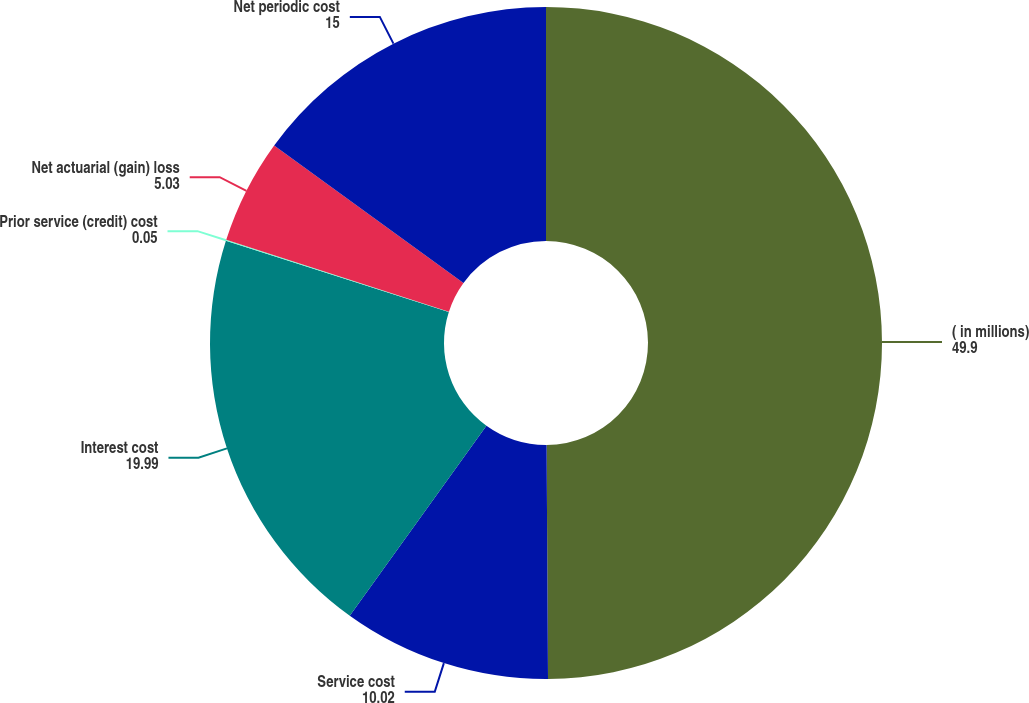Convert chart to OTSL. <chart><loc_0><loc_0><loc_500><loc_500><pie_chart><fcel>( in millions)<fcel>Service cost<fcel>Interest cost<fcel>Prior service (credit) cost<fcel>Net actuarial (gain) loss<fcel>Net periodic cost<nl><fcel>49.9%<fcel>10.02%<fcel>19.99%<fcel>0.05%<fcel>5.03%<fcel>15.0%<nl></chart> 